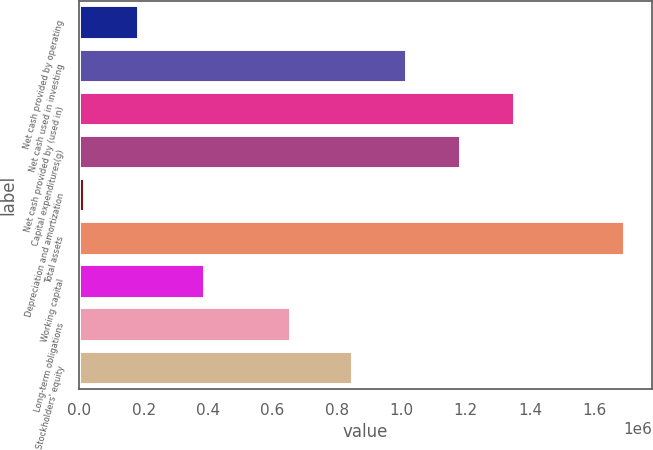Convert chart. <chart><loc_0><loc_0><loc_500><loc_500><bar_chart><fcel>Net cash provided by operating<fcel>Net cash used in investing<fcel>Net cash provided by (used in)<fcel>Capital expenditures(g)<fcel>Depreciation and amortization<fcel>Total assets<fcel>Working capital<fcel>Long-term obligations<fcel>Stockholders' equity<nl><fcel>185482<fcel>1.01724e+06<fcel>1.35217e+06<fcel>1.1847e+06<fcel>18018<fcel>1.69266e+06<fcel>389469<fcel>658462<fcel>849777<nl></chart> 